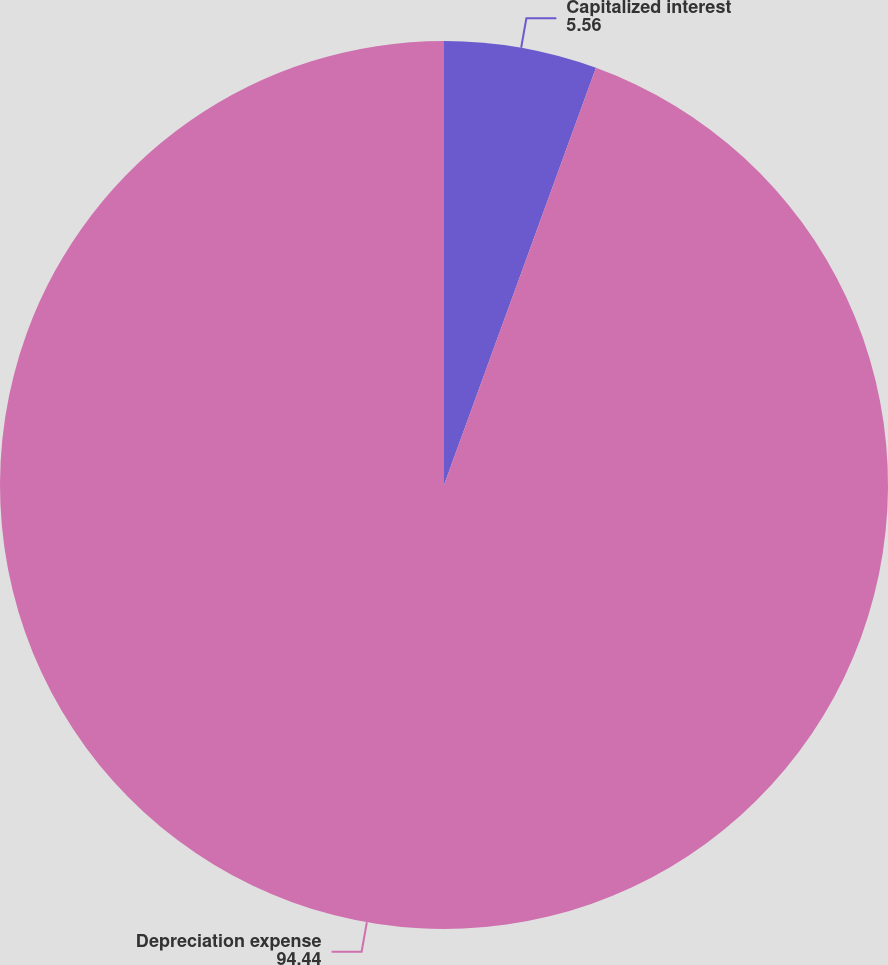<chart> <loc_0><loc_0><loc_500><loc_500><pie_chart><fcel>Capitalized interest<fcel>Depreciation expense<nl><fcel>5.56%<fcel>94.44%<nl></chart> 